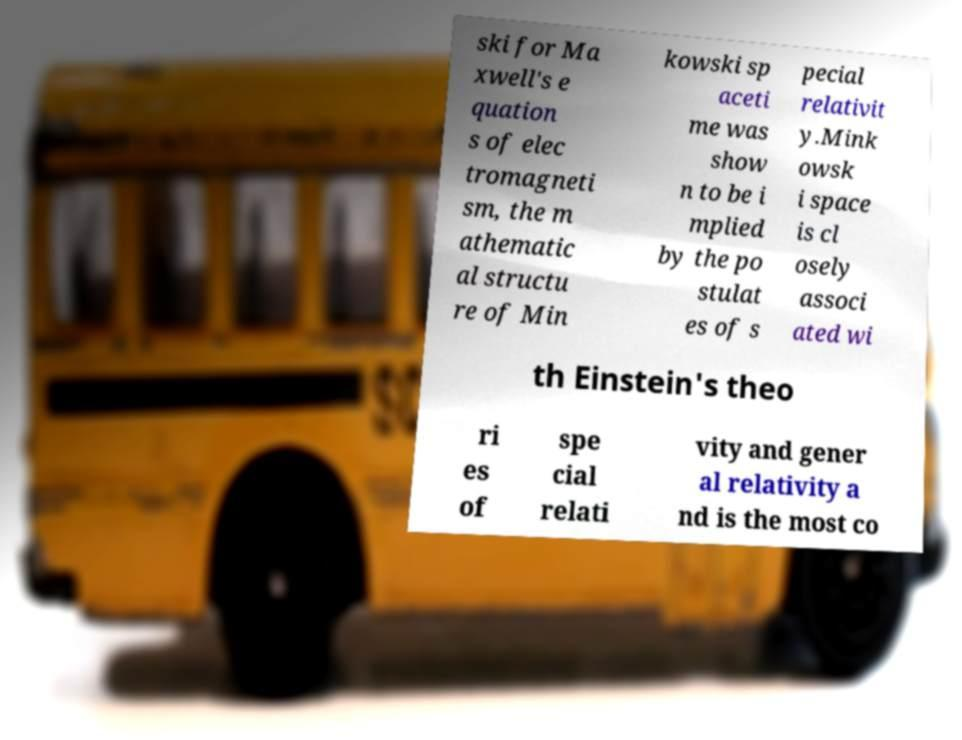I need the written content from this picture converted into text. Can you do that? ski for Ma xwell's e quation s of elec tromagneti sm, the m athematic al structu re of Min kowski sp aceti me was show n to be i mplied by the po stulat es of s pecial relativit y.Mink owsk i space is cl osely associ ated wi th Einstein's theo ri es of spe cial relati vity and gener al relativity a nd is the most co 